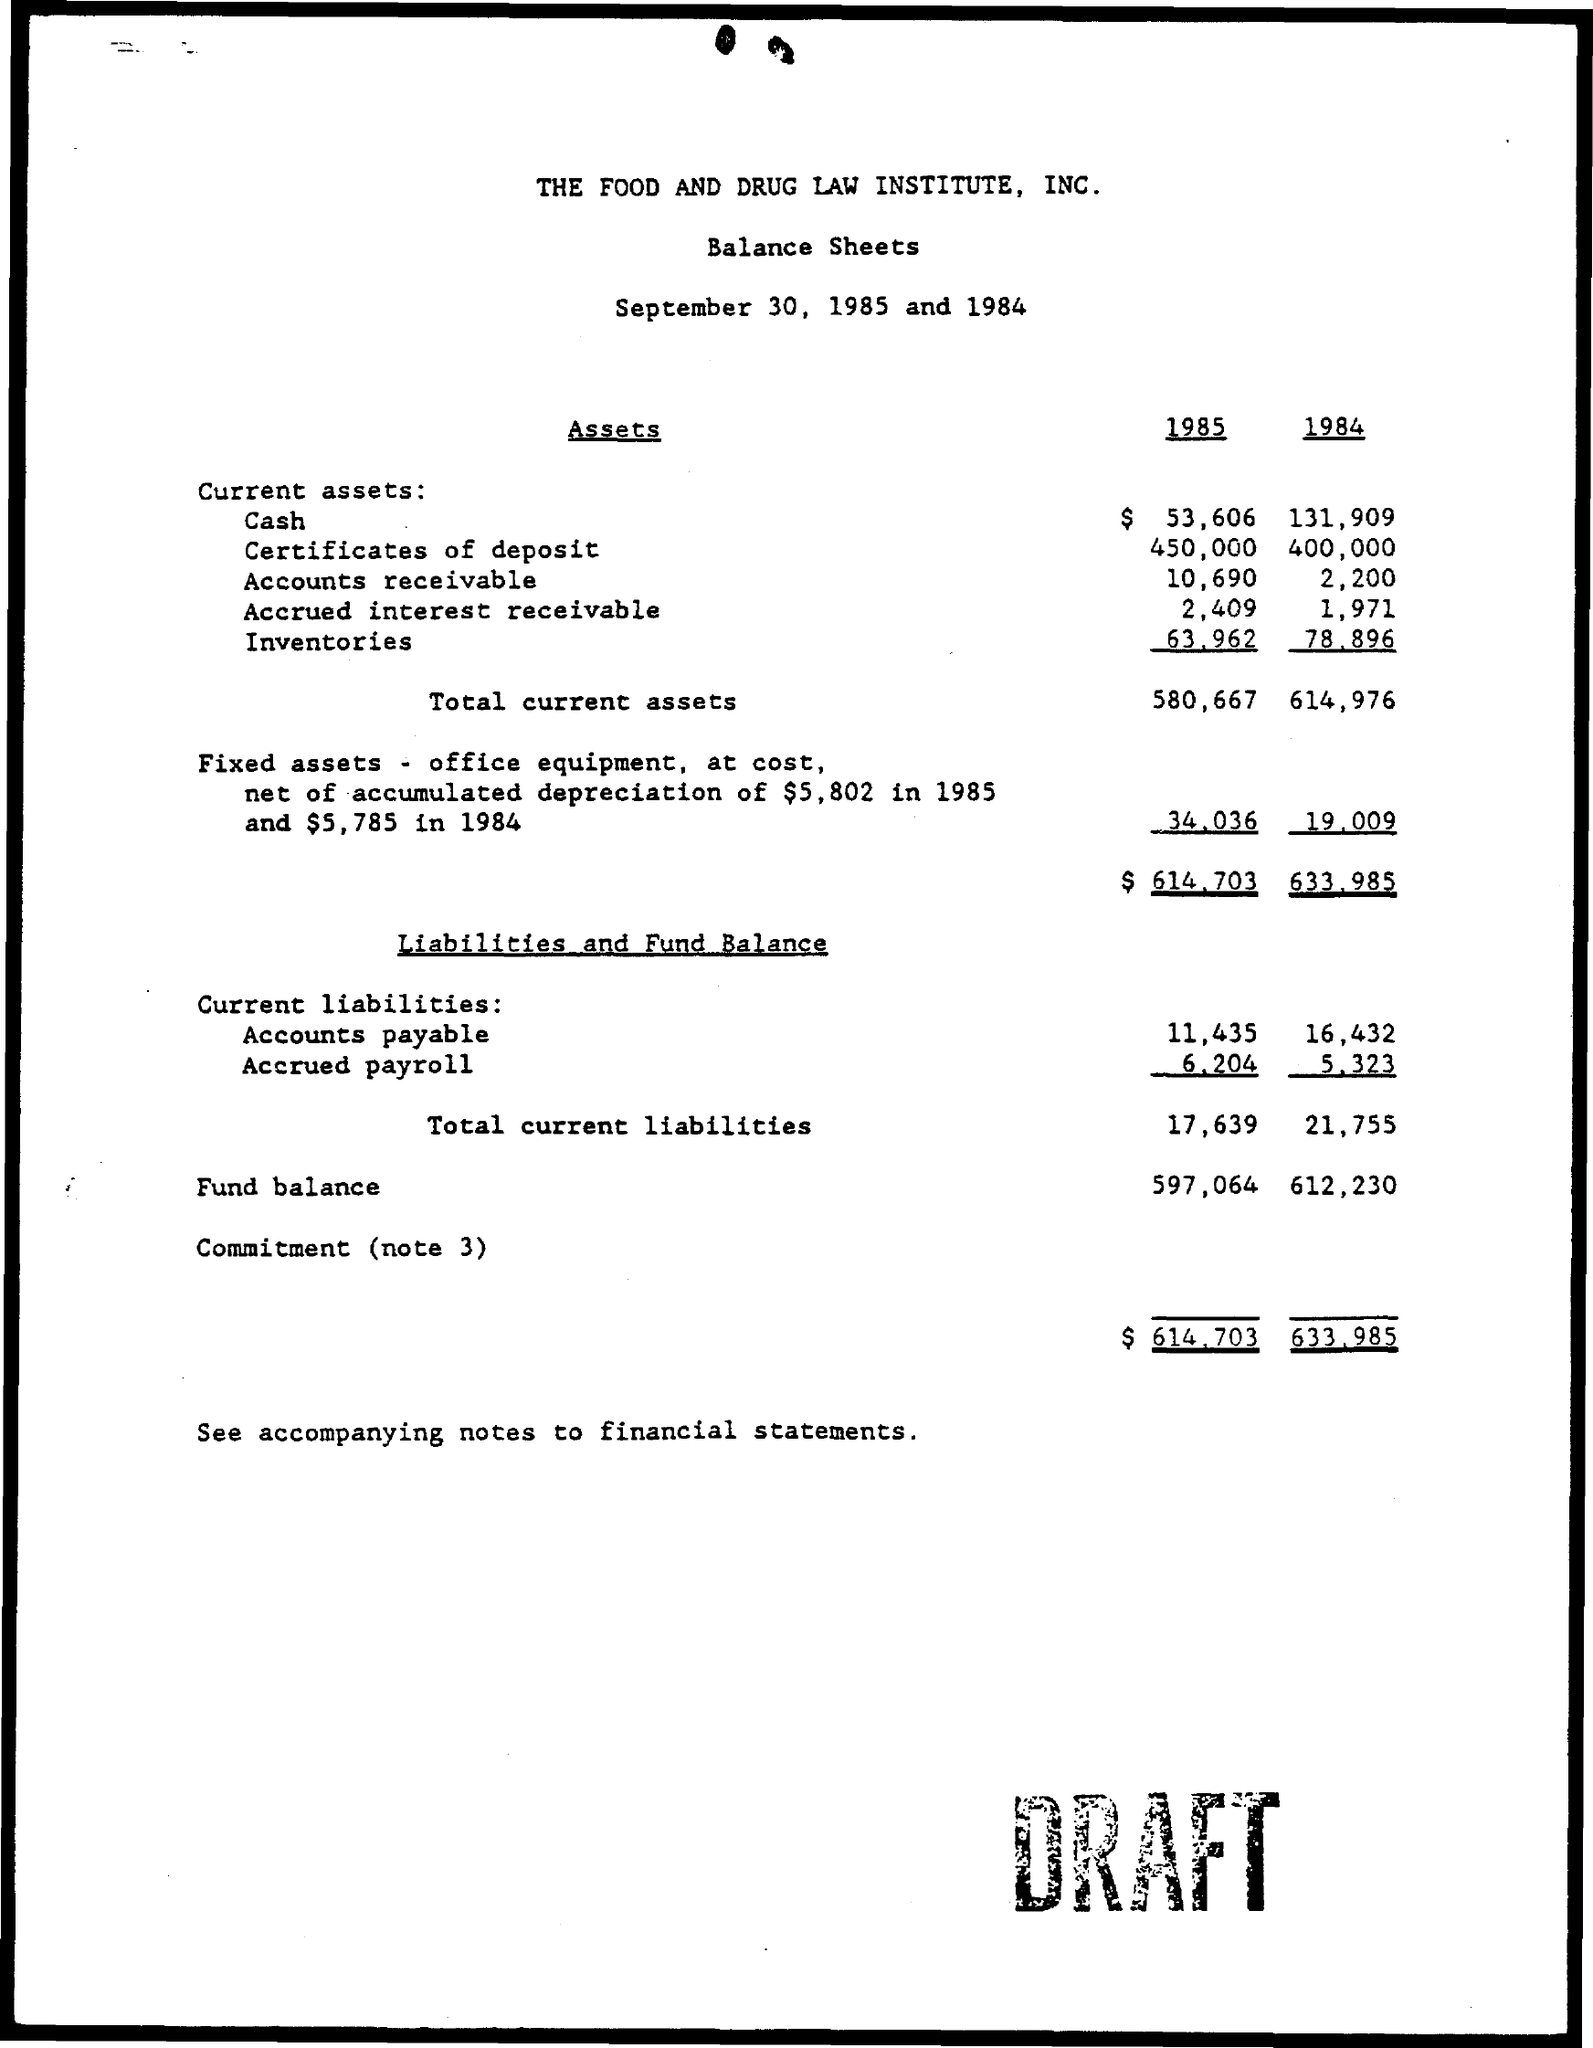Point out several critical features in this image. In the year 1985, the total current assets were 580,667. The total current liabilities in the year 1984 was 21,755. 